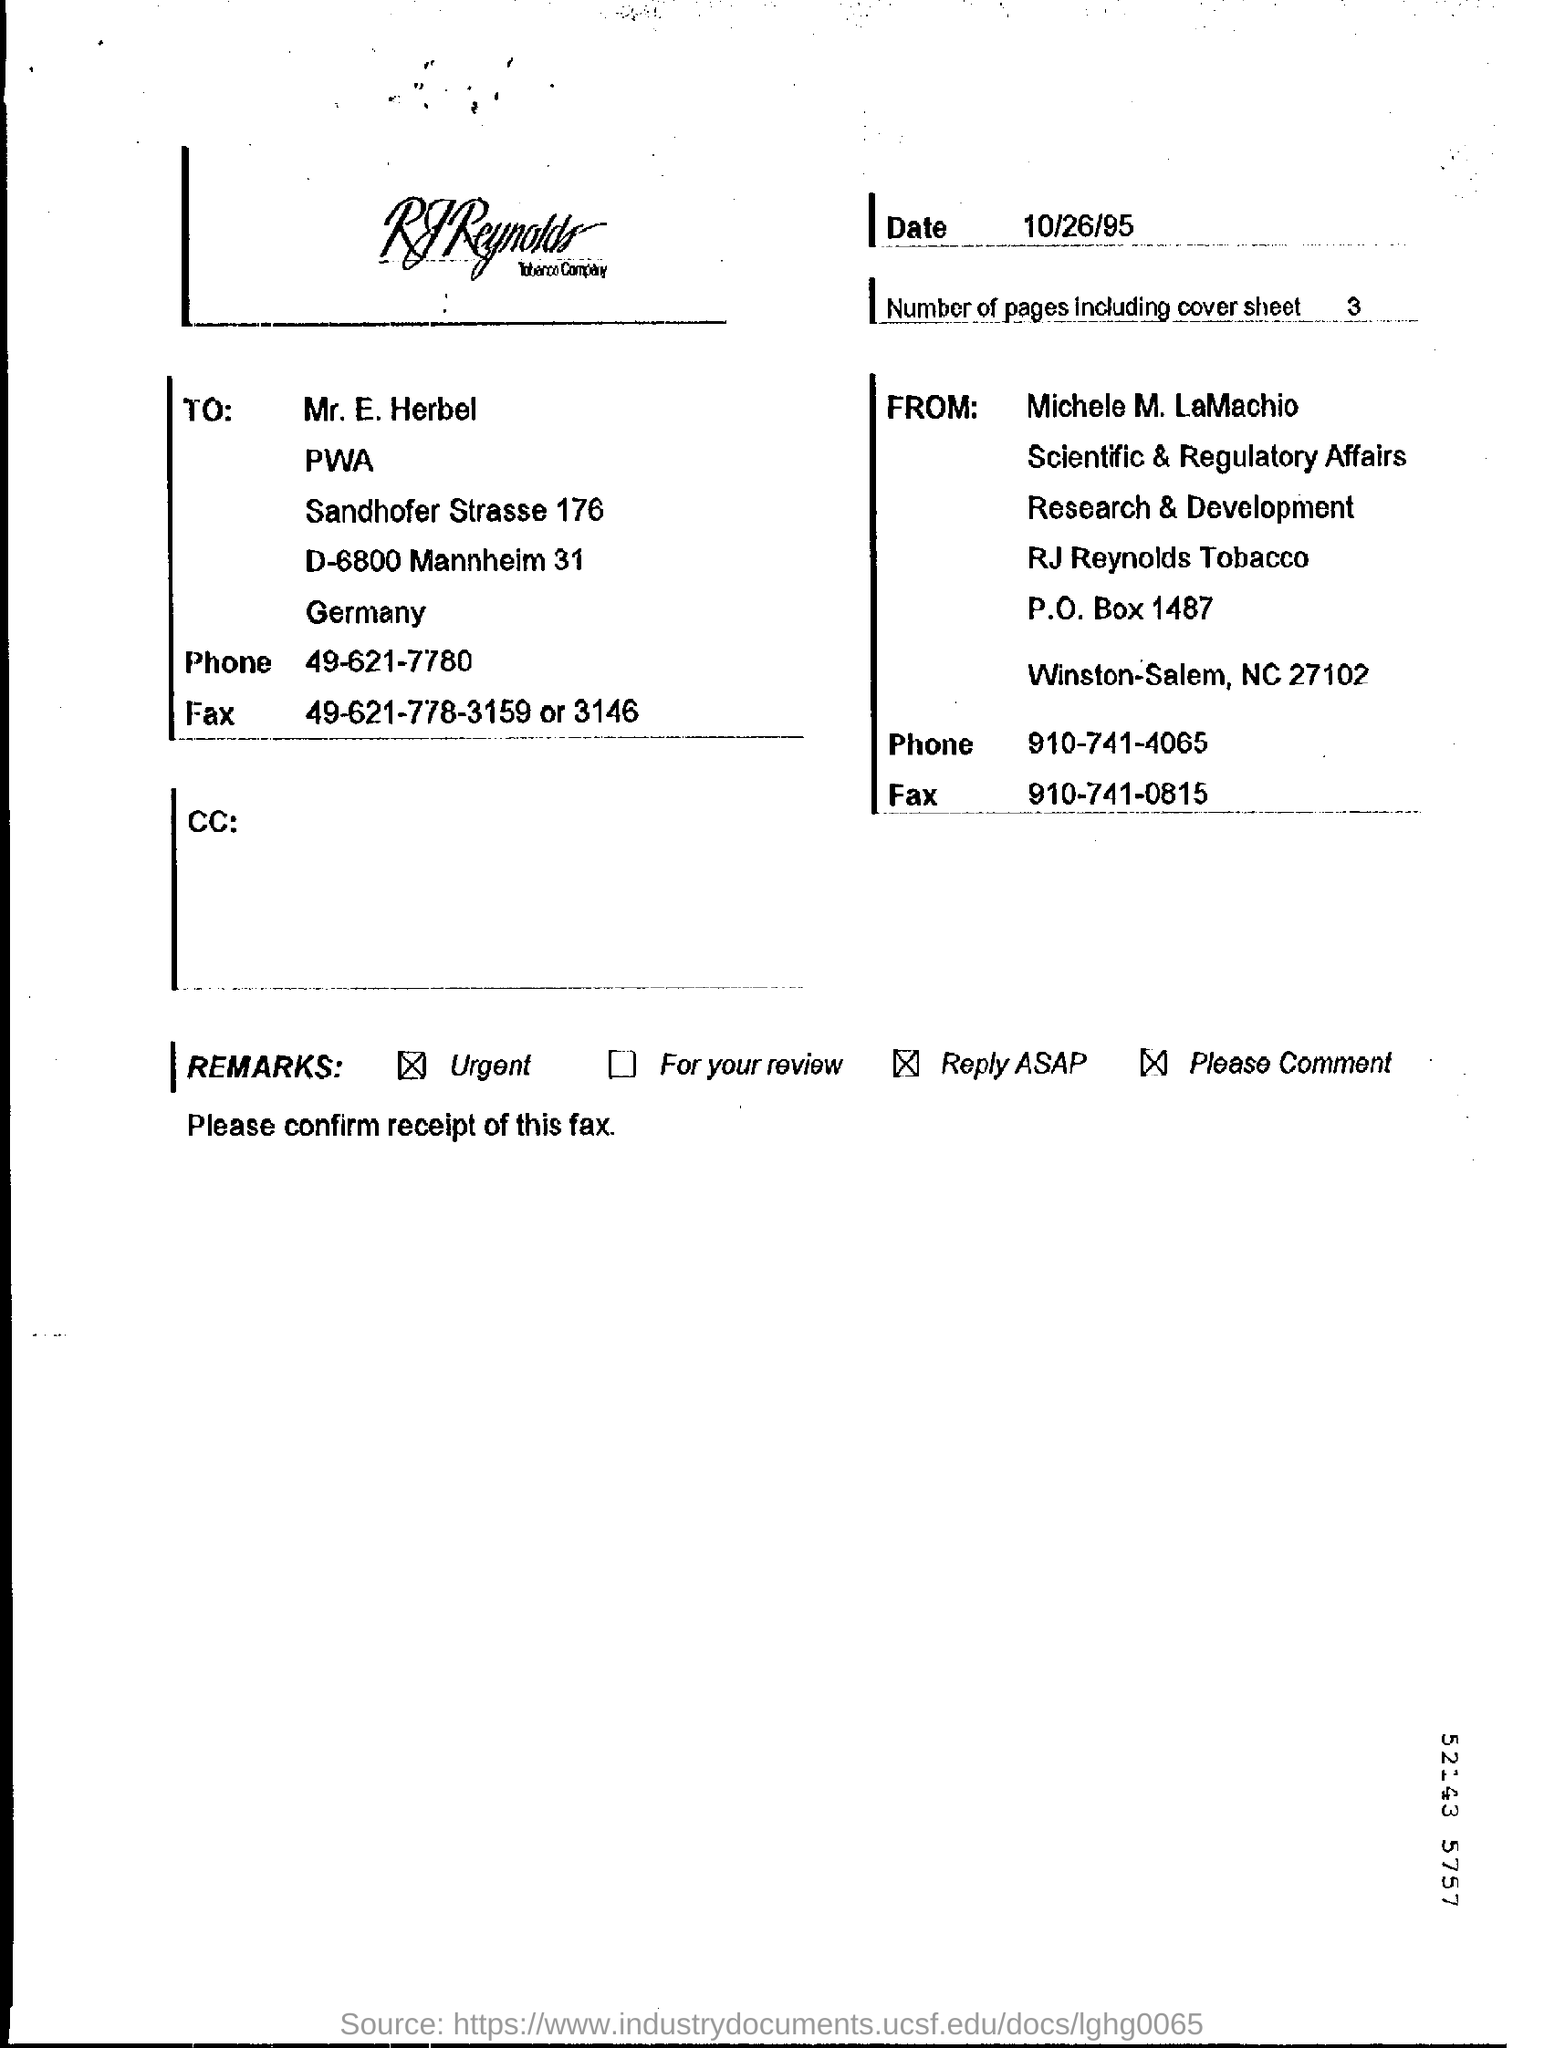How many number of pages including cover sheet ?
Offer a terse response. 3. 